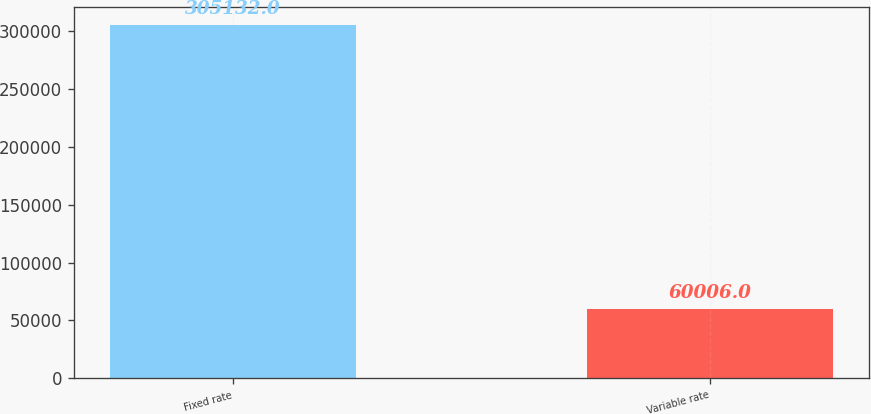<chart> <loc_0><loc_0><loc_500><loc_500><bar_chart><fcel>Fixed rate<fcel>Variable rate<nl><fcel>305132<fcel>60006<nl></chart> 